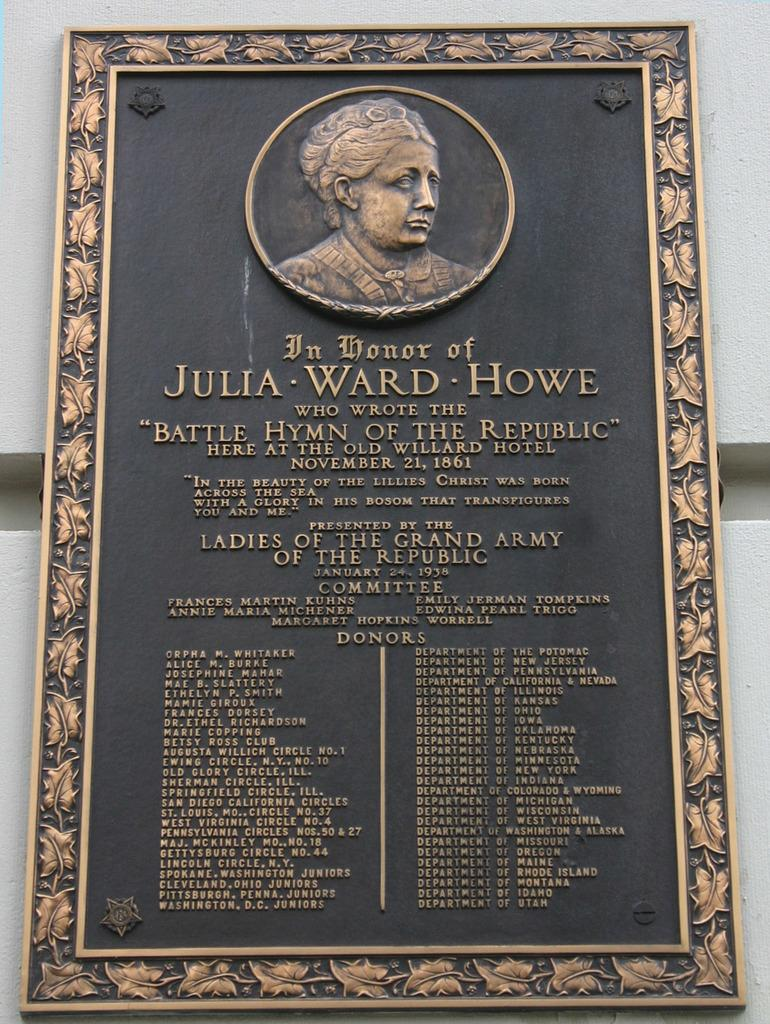Provide a one-sentence caption for the provided image. A dedication sign with a woman's picture on it and Julia Ward Howe on it. 